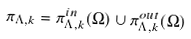Convert formula to latex. <formula><loc_0><loc_0><loc_500><loc_500>\pi _ { \Lambda , k } = \pi _ { \Lambda , k } ^ { i n } ( \Omega ) \cup \pi _ { \Lambda , k } ^ { o u t } ( \Omega )</formula> 